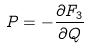<formula> <loc_0><loc_0><loc_500><loc_500>P = - \frac { \partial F _ { 3 } } { \partial Q }</formula> 